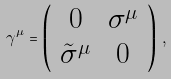<formula> <loc_0><loc_0><loc_500><loc_500>\gamma ^ { \mu } = \left ( \begin{array} { c c } 0 & \sigma ^ { \mu } \\ \tilde { \sigma } ^ { \mu } & 0 \end{array} \right ) \, ,</formula> 